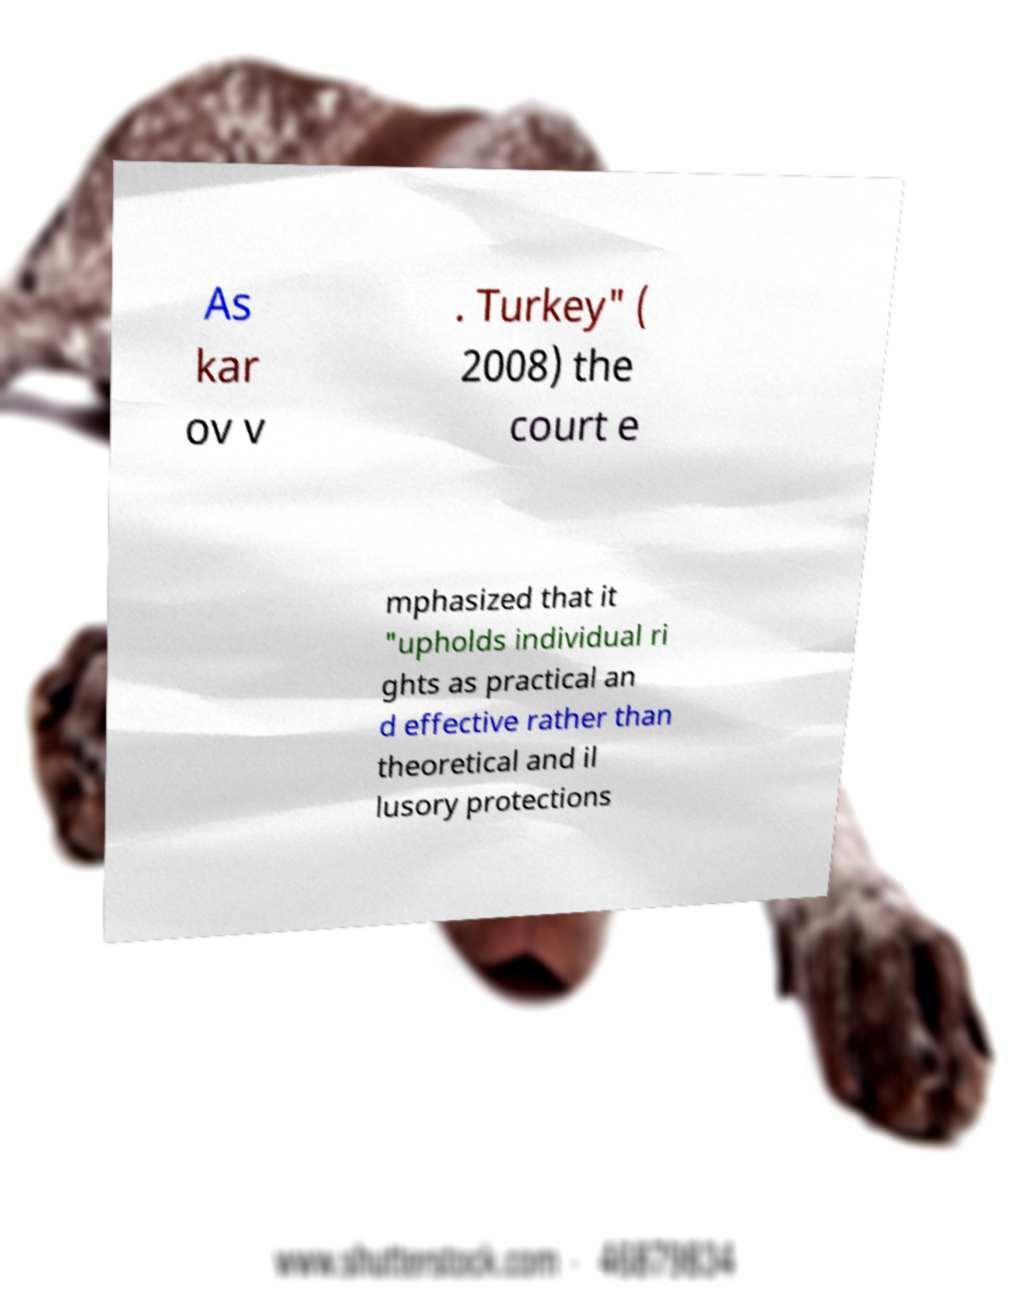Please identify and transcribe the text found in this image. As kar ov v . Turkey" ( 2008) the court e mphasized that it "upholds individual ri ghts as practical an d effective rather than theoretical and il lusory protections 